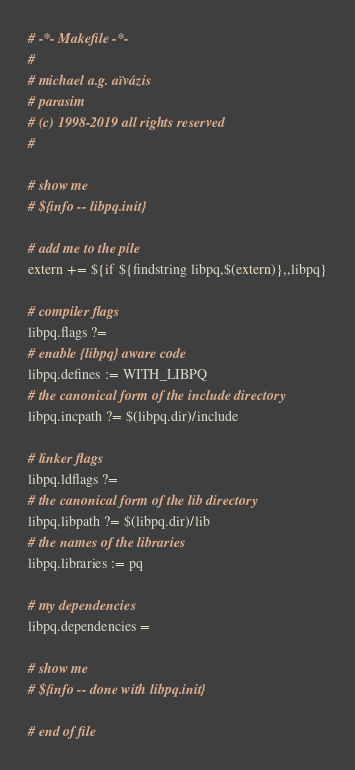<code> <loc_0><loc_0><loc_500><loc_500><_ObjectiveC_># -*- Makefile -*-
#
# michael a.g. aïvázis
# parasim
# (c) 1998-2019 all rights reserved
#

# show me
# ${info -- libpq.init}

# add me to the pile
extern += ${if ${findstring libpq,$(extern)},,libpq}

# compiler flags
libpq.flags ?=
# enable {libpq} aware code
libpq.defines := WITH_LIBPQ
# the canonical form of the include directory
libpq.incpath ?= $(libpq.dir)/include

# linker flags
libpq.ldflags ?=
# the canonical form of the lib directory
libpq.libpath ?= $(libpq.dir)/lib
# the names of the libraries
libpq.libraries := pq

# my dependencies
libpq.dependencies =

# show me
# ${info -- done with libpq.init}

# end of file
</code> 